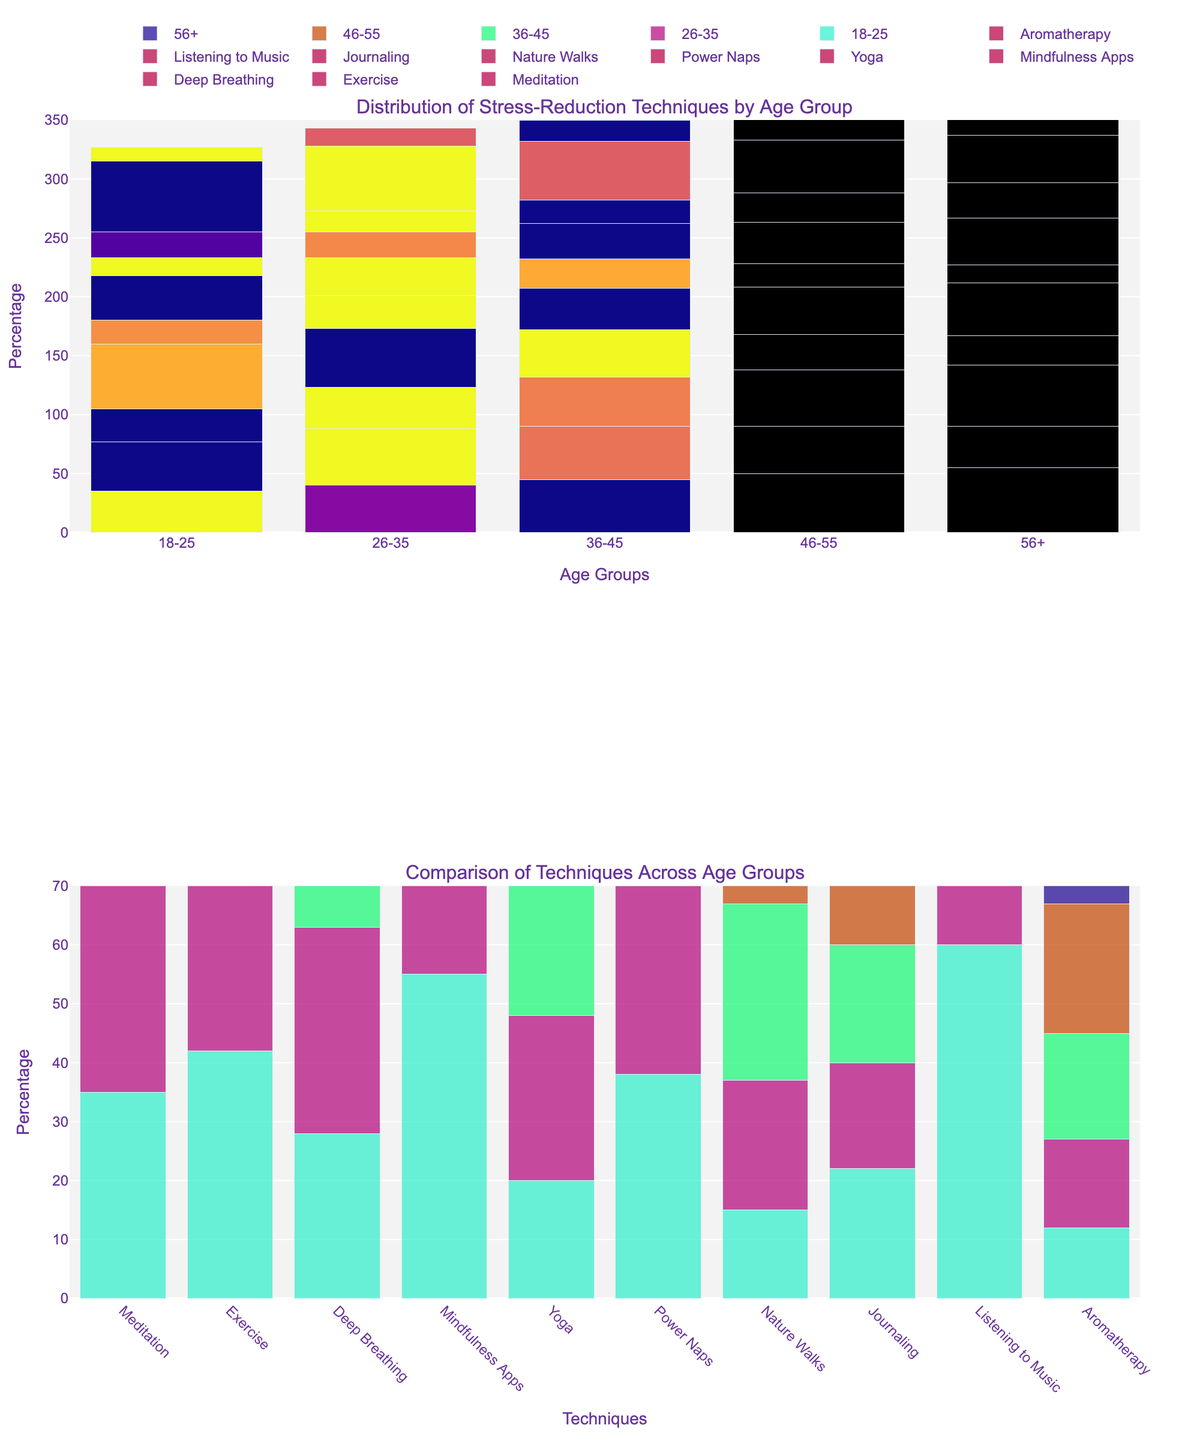what is the most popular stress-reduction technique for the age group 18-25? By observing the first subplot, the tallest bar for the age group 18-25 indicates the most popular technique. It is 'Listening to Music' with a value of 60%.
Answer: Listening to Music which age group has the highest percentage of people using yoga? By looking at the highest bar for the 'Yoga' technique across age groups in the first subplot, the 56+ age group has the highest value at 45%.
Answer: 56+ what is the combined percentage of Meditation and Exercise for the age group 36-45? Sum the percentages of Meditation (45) and Exercise (45) for the 36-45 age group shown in the first subplot. 45 + 45 = 90
Answer: 90 how much higher is the usage of mindfulness apps in the 18-25 age group compared to the 56+ age group? Compare the 'Mindfulness Apps' bars for the 18-25 (55%) and 56+ (25%) age groups. Subtract the lower percentage from the higher one: 55 - 25 = 30
Answer: 30 which stress-reduction technique is the least popular among all age groups? In both subplots, observe the height of the bars. 'Aromatherapy' has the smallest values across all age groups, with a maximum of 25% in the 56+ group.
Answer: Aromatherapy how does the usage of nature walks change with increasing age? Observe the 'Nature Walks' bars in the first subplot. As the age increases from 18-25 to 56+, the height of the bars increases, indicating more usage among older age groups.
Answer: Increases what stress-reduction technique has the most significant variation in use among different age groups? Comparing the range of heights for each technique in the first subplot, 'Mindfulness Apps' shows significant variation, ranging from 25% for the 56+ group to 55% for the 18-25 group.
Answer: Mindfulness Apps which technique is equally popular in two different age groups? 'Exercise' shows bars of equal height (48%) in the age groups 26-35 and 36-45 in the first subplot.
Answer: Exercise what is the difference in the total usage of stress-reduction techniques between the youngest and the oldest age groups? Sum the percentages of all techniques for both 18-25 and 56+ age groups. 
Advantages for the 18-25 age group (35+42+28+55+20+38+15+22+60+12 = 327)
Advantages for the 56+ age group (55+35+52+25+45+15+40+30+40+25 = 362)
Subtract the sums: 362 - 327 = 35.
Answer: 35 Which age group has the most diversity in stress-reduction techniques (the broadest range of values)? Among all mentioned age groups, observe the range (difference between the highest and lowest values) of value heights across various stress-reduction techniques. The 18-25 age group has highs of 60 (Listening to Music) and lows of 12 (Aromatherapy) resulting in the difference: 60 - 12 = 48, which is the broadest.
Answer: 18-25 